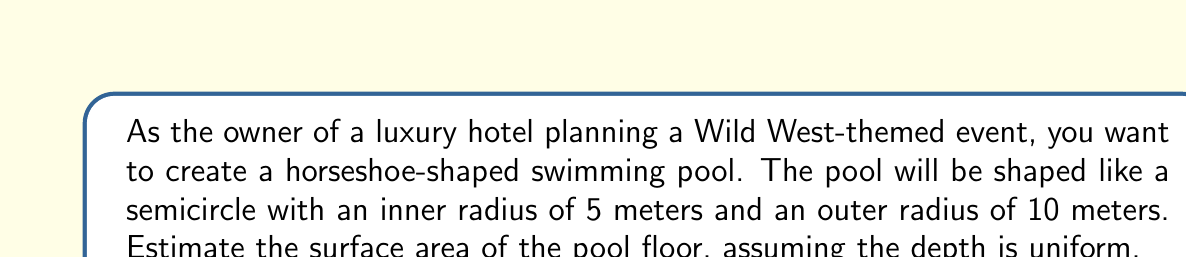Teach me how to tackle this problem. To estimate the surface area of the horseshoe-shaped pool, we need to calculate the area of the larger semicircle and subtract the area of the smaller semicircle.

1. Area of a circle: $A = \pi r^2$
2. Area of a semicircle: $A = \frac{1}{2} \pi r^2$

Let's calculate step by step:

1. Area of the larger semicircle (outer radius = 10 m):
   $$A_1 = \frac{1}{2} \pi (10\text{ m})^2 = 50\pi \text{ m}^2$$

2. Area of the smaller semicircle (inner radius = 5 m):
   $$A_2 = \frac{1}{2} \pi (5\text{ m})^2 = 12.5\pi \text{ m}^2$$

3. Surface area of the pool floor:
   $$A_{\text{pool}} = A_1 - A_2 = 50\pi \text{ m}^2 - 12.5\pi \text{ m}^2 = 37.5\pi \text{ m}^2$$

4. Calculate the final value:
   $$A_{\text{pool}} = 37.5\pi \text{ m}^2 \approx 117.81 \text{ m}^2$$

[asy]
size(200);
fill(circle((0,0),10),lightgray);
fill(circle((0,0),5),white);
draw(arc((0,0),10,0,180));
draw(arc((0,0),5,0,180));
label("10 m", (5,0), S);
label("5 m", (2.5,0), N);
[/asy]
Answer: The estimated surface area of the horseshoe-shaped swimming pool is approximately 117.81 square meters. 